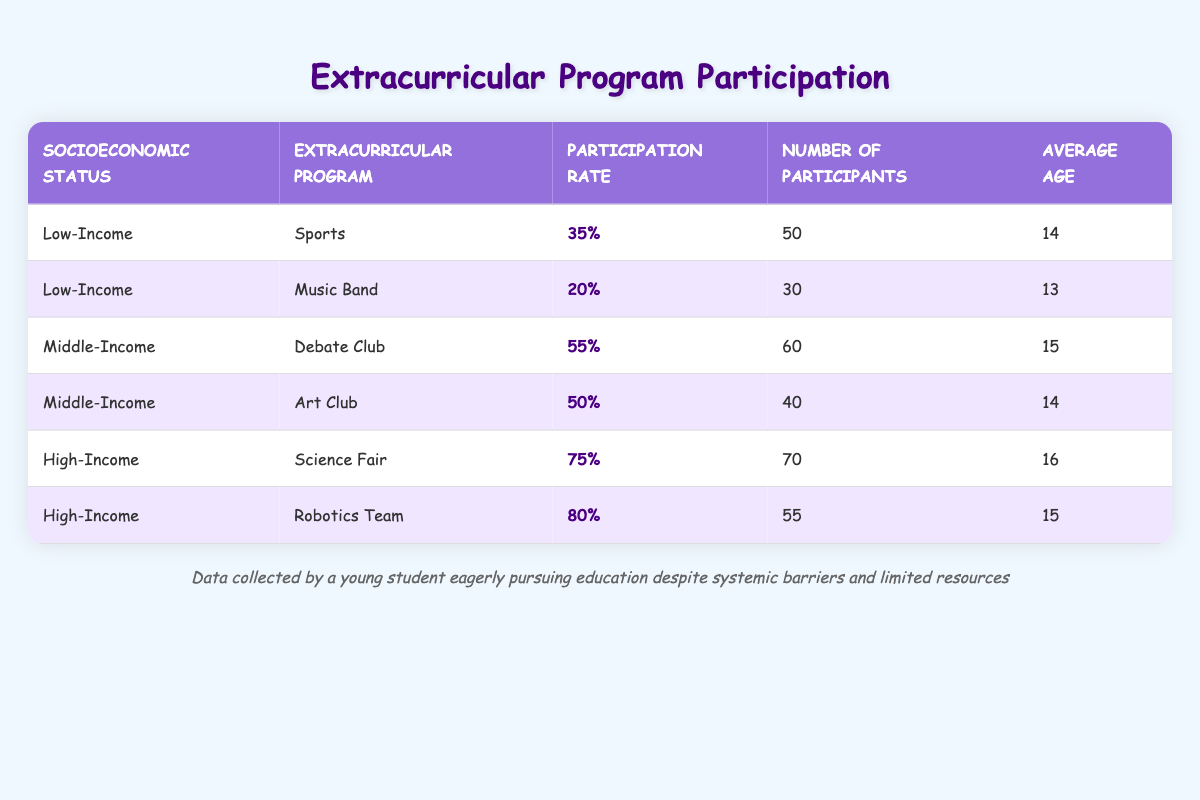What is the participation rate for the Music Band in the Low-Income category? The table shows that the participation rate for the Music Band under the Low-Income category is specifically listed as 20%.
Answer: 20% Which extracurricular program has the highest participation rate? By examining the participation rates in the table, the Robotics Team under the High-Income category is the highest with a rate of 80%.
Answer: Robotics Team How many participants are in the Sports program for Low-Income students? The table indicates that there are 50 participants in the Sports program for students classified as Low-Income.
Answer: 50 What is the average participation rate for Middle-Income programs? To find the average participation rate for Middle-Income programs, add the rates: 55% (Debate Club) + 50% (Art Club) = 105%. There are 2 programs, so the average is 105% / 2 = 52.5%.
Answer: 52.5% Is the average age of participants in the Science Fair greater than 15? The table shows that the average age of participants in the Science Fair is 16, which is indeed greater than 15.
Answer: Yes How many more participants are in the Science Fair compared to the Debate Club? The Science Fair has 70 participants while the Debate Club has 60. To find the difference, subtract the number of Debate Club participants from the Science Fair: 70 - 60 = 10.
Answer: 10 Which socioeconomic status group has a lower average age, Low-Income or Middle-Income participants? The average age for Low-Income participants is 13.5 years (average of 14 and 13 from Sports and Music Band), while for Middle-Income it's 14.5 years (average of 15 and 14 from Debate Club and Art Club). Since 13.5 < 14.5, Low-Income has a lower average age.
Answer: Low-Income What percentage of participants in High-Income programs are involved in the Science Fair? There are a total of 70 participants in the Science Fair and 55 in the Robotics Team, making a total of 125 participants in High-Income programs. The percentage involved in the Science Fair is (70 / 125) * 100 = 56%.
Answer: 56% Are there any Low-Income programs with a participation rate greater than 30%? The table shows 35% for Sports and 20% for Music Band; therefore, there is only one program, Sports, that has a participation rate greater than 30%.
Answer: Yes 